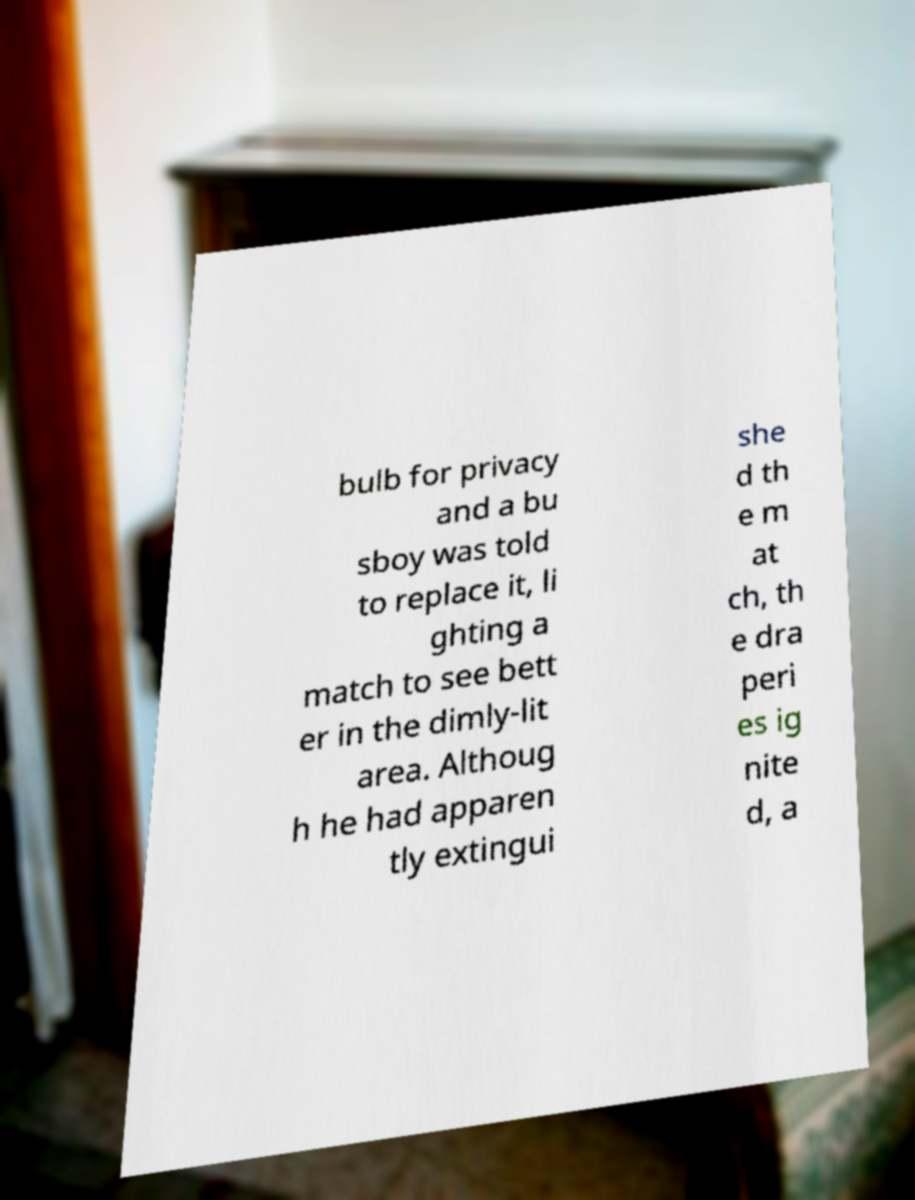There's text embedded in this image that I need extracted. Can you transcribe it verbatim? bulb for privacy and a bu sboy was told to replace it, li ghting a match to see bett er in the dimly-lit area. Althoug h he had apparen tly extingui she d th e m at ch, th e dra peri es ig nite d, a 